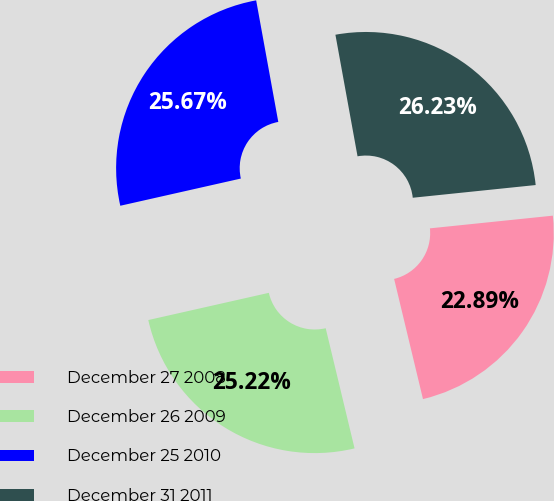Convert chart to OTSL. <chart><loc_0><loc_0><loc_500><loc_500><pie_chart><fcel>December 27 2008<fcel>December 26 2009<fcel>December 25 2010<fcel>December 31 2011<nl><fcel>22.89%<fcel>25.22%<fcel>25.67%<fcel>26.23%<nl></chart> 